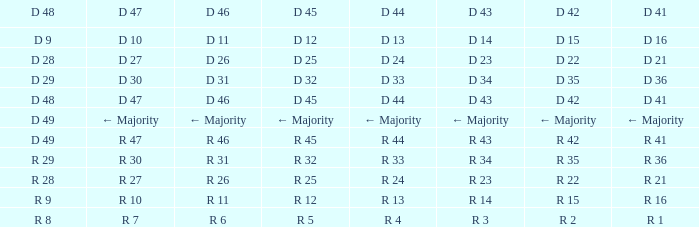Identify the d 47 when it possesses a d 45 of d 3 D 30. 